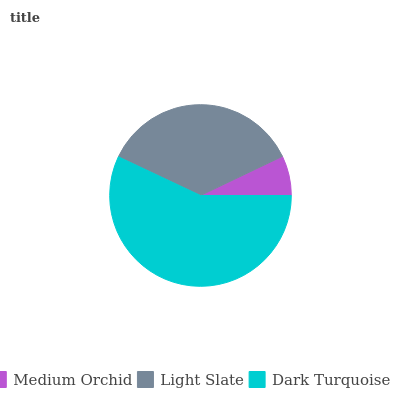Is Medium Orchid the minimum?
Answer yes or no. Yes. Is Dark Turquoise the maximum?
Answer yes or no. Yes. Is Light Slate the minimum?
Answer yes or no. No. Is Light Slate the maximum?
Answer yes or no. No. Is Light Slate greater than Medium Orchid?
Answer yes or no. Yes. Is Medium Orchid less than Light Slate?
Answer yes or no. Yes. Is Medium Orchid greater than Light Slate?
Answer yes or no. No. Is Light Slate less than Medium Orchid?
Answer yes or no. No. Is Light Slate the high median?
Answer yes or no. Yes. Is Light Slate the low median?
Answer yes or no. Yes. Is Medium Orchid the high median?
Answer yes or no. No. Is Medium Orchid the low median?
Answer yes or no. No. 